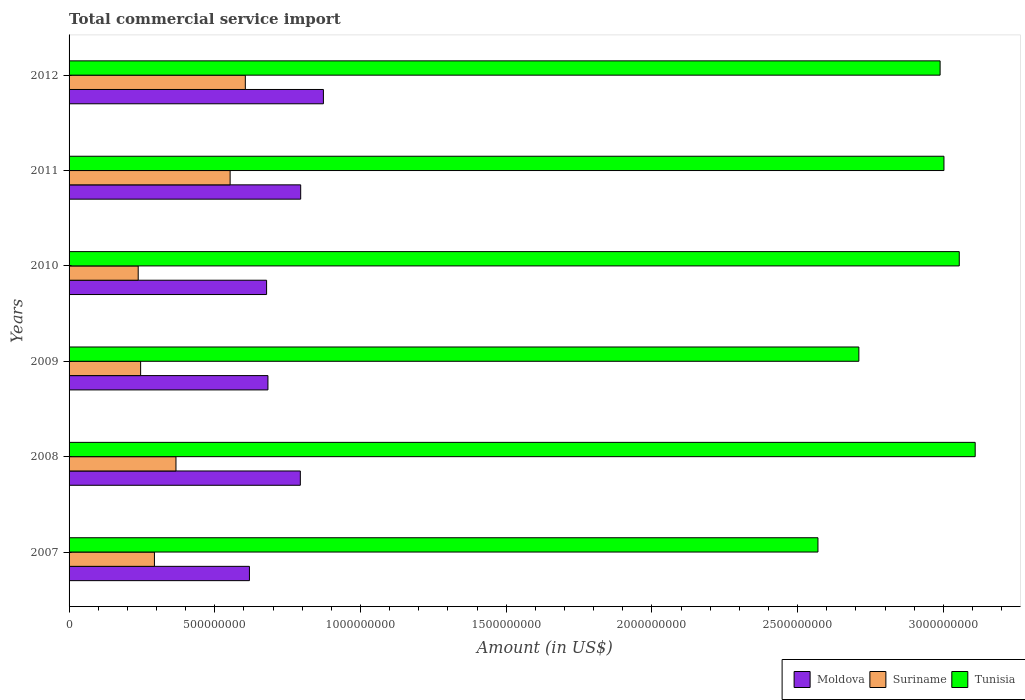How many groups of bars are there?
Make the answer very short. 6. Are the number of bars per tick equal to the number of legend labels?
Ensure brevity in your answer.  Yes. Are the number of bars on each tick of the Y-axis equal?
Make the answer very short. Yes. In how many cases, is the number of bars for a given year not equal to the number of legend labels?
Provide a succinct answer. 0. What is the total commercial service import in Suriname in 2009?
Your answer should be compact. 2.46e+08. Across all years, what is the maximum total commercial service import in Tunisia?
Your answer should be compact. 3.11e+09. Across all years, what is the minimum total commercial service import in Moldova?
Offer a very short reply. 6.19e+08. In which year was the total commercial service import in Suriname maximum?
Provide a short and direct response. 2012. In which year was the total commercial service import in Tunisia minimum?
Give a very brief answer. 2007. What is the total total commercial service import in Moldova in the graph?
Provide a short and direct response. 4.44e+09. What is the difference between the total commercial service import in Suriname in 2007 and that in 2012?
Provide a short and direct response. -3.12e+08. What is the difference between the total commercial service import in Moldova in 2009 and the total commercial service import in Tunisia in 2012?
Your answer should be compact. -2.31e+09. What is the average total commercial service import in Moldova per year?
Make the answer very short. 7.40e+08. In the year 2009, what is the difference between the total commercial service import in Tunisia and total commercial service import in Moldova?
Your answer should be very brief. 2.03e+09. What is the ratio of the total commercial service import in Tunisia in 2007 to that in 2011?
Keep it short and to the point. 0.86. What is the difference between the highest and the second highest total commercial service import in Tunisia?
Make the answer very short. 5.46e+07. What is the difference between the highest and the lowest total commercial service import in Tunisia?
Give a very brief answer. 5.40e+08. In how many years, is the total commercial service import in Moldova greater than the average total commercial service import in Moldova taken over all years?
Offer a terse response. 3. What does the 3rd bar from the top in 2012 represents?
Ensure brevity in your answer.  Moldova. What does the 1st bar from the bottom in 2010 represents?
Your answer should be compact. Moldova. Is it the case that in every year, the sum of the total commercial service import in Moldova and total commercial service import in Tunisia is greater than the total commercial service import in Suriname?
Ensure brevity in your answer.  Yes. How many bars are there?
Your answer should be very brief. 18. How many years are there in the graph?
Give a very brief answer. 6. What is the difference between two consecutive major ticks on the X-axis?
Provide a short and direct response. 5.00e+08. Does the graph contain any zero values?
Offer a terse response. No. What is the title of the graph?
Give a very brief answer. Total commercial service import. Does "East Asia (developing only)" appear as one of the legend labels in the graph?
Offer a terse response. No. What is the label or title of the X-axis?
Give a very brief answer. Amount (in US$). What is the Amount (in US$) of Moldova in 2007?
Your answer should be very brief. 6.19e+08. What is the Amount (in US$) of Suriname in 2007?
Ensure brevity in your answer.  2.93e+08. What is the Amount (in US$) of Tunisia in 2007?
Your answer should be compact. 2.57e+09. What is the Amount (in US$) in Moldova in 2008?
Your response must be concise. 7.94e+08. What is the Amount (in US$) of Suriname in 2008?
Offer a very short reply. 3.67e+08. What is the Amount (in US$) of Tunisia in 2008?
Provide a succinct answer. 3.11e+09. What is the Amount (in US$) in Moldova in 2009?
Your response must be concise. 6.82e+08. What is the Amount (in US$) of Suriname in 2009?
Your answer should be very brief. 2.46e+08. What is the Amount (in US$) in Tunisia in 2009?
Provide a succinct answer. 2.71e+09. What is the Amount (in US$) in Moldova in 2010?
Your answer should be very brief. 6.78e+08. What is the Amount (in US$) of Suriname in 2010?
Your answer should be very brief. 2.37e+08. What is the Amount (in US$) of Tunisia in 2010?
Provide a succinct answer. 3.05e+09. What is the Amount (in US$) of Moldova in 2011?
Your answer should be very brief. 7.95e+08. What is the Amount (in US$) in Suriname in 2011?
Give a very brief answer. 5.53e+08. What is the Amount (in US$) in Tunisia in 2011?
Give a very brief answer. 3.00e+09. What is the Amount (in US$) of Moldova in 2012?
Provide a short and direct response. 8.73e+08. What is the Amount (in US$) in Suriname in 2012?
Provide a succinct answer. 6.05e+08. What is the Amount (in US$) of Tunisia in 2012?
Ensure brevity in your answer.  2.99e+09. Across all years, what is the maximum Amount (in US$) in Moldova?
Your answer should be compact. 8.73e+08. Across all years, what is the maximum Amount (in US$) in Suriname?
Offer a terse response. 6.05e+08. Across all years, what is the maximum Amount (in US$) in Tunisia?
Offer a terse response. 3.11e+09. Across all years, what is the minimum Amount (in US$) in Moldova?
Provide a short and direct response. 6.19e+08. Across all years, what is the minimum Amount (in US$) of Suriname?
Your answer should be very brief. 2.37e+08. Across all years, what is the minimum Amount (in US$) of Tunisia?
Provide a succinct answer. 2.57e+09. What is the total Amount (in US$) of Moldova in the graph?
Your answer should be compact. 4.44e+09. What is the total Amount (in US$) in Suriname in the graph?
Your response must be concise. 2.30e+09. What is the total Amount (in US$) in Tunisia in the graph?
Provide a succinct answer. 1.74e+1. What is the difference between the Amount (in US$) in Moldova in 2007 and that in 2008?
Your answer should be compact. -1.75e+08. What is the difference between the Amount (in US$) in Suriname in 2007 and that in 2008?
Provide a short and direct response. -7.39e+07. What is the difference between the Amount (in US$) of Tunisia in 2007 and that in 2008?
Provide a short and direct response. -5.40e+08. What is the difference between the Amount (in US$) of Moldova in 2007 and that in 2009?
Make the answer very short. -6.35e+07. What is the difference between the Amount (in US$) of Suriname in 2007 and that in 2009?
Offer a terse response. 4.74e+07. What is the difference between the Amount (in US$) of Tunisia in 2007 and that in 2009?
Your response must be concise. -1.40e+08. What is the difference between the Amount (in US$) in Moldova in 2007 and that in 2010?
Offer a terse response. -5.89e+07. What is the difference between the Amount (in US$) in Suriname in 2007 and that in 2010?
Offer a very short reply. 5.57e+07. What is the difference between the Amount (in US$) of Tunisia in 2007 and that in 2010?
Provide a short and direct response. -4.85e+08. What is the difference between the Amount (in US$) of Moldova in 2007 and that in 2011?
Offer a terse response. -1.76e+08. What is the difference between the Amount (in US$) of Suriname in 2007 and that in 2011?
Ensure brevity in your answer.  -2.60e+08. What is the difference between the Amount (in US$) in Tunisia in 2007 and that in 2011?
Offer a very short reply. -4.32e+08. What is the difference between the Amount (in US$) in Moldova in 2007 and that in 2012?
Your response must be concise. -2.54e+08. What is the difference between the Amount (in US$) of Suriname in 2007 and that in 2012?
Your answer should be very brief. -3.12e+08. What is the difference between the Amount (in US$) in Tunisia in 2007 and that in 2012?
Ensure brevity in your answer.  -4.19e+08. What is the difference between the Amount (in US$) of Moldova in 2008 and that in 2009?
Provide a short and direct response. 1.11e+08. What is the difference between the Amount (in US$) of Suriname in 2008 and that in 2009?
Keep it short and to the point. 1.21e+08. What is the difference between the Amount (in US$) of Tunisia in 2008 and that in 2009?
Provide a succinct answer. 3.99e+08. What is the difference between the Amount (in US$) in Moldova in 2008 and that in 2010?
Offer a very short reply. 1.16e+08. What is the difference between the Amount (in US$) of Suriname in 2008 and that in 2010?
Your response must be concise. 1.30e+08. What is the difference between the Amount (in US$) in Tunisia in 2008 and that in 2010?
Offer a very short reply. 5.46e+07. What is the difference between the Amount (in US$) of Moldova in 2008 and that in 2011?
Offer a very short reply. -1.20e+06. What is the difference between the Amount (in US$) of Suriname in 2008 and that in 2011?
Your response must be concise. -1.86e+08. What is the difference between the Amount (in US$) of Tunisia in 2008 and that in 2011?
Offer a very short reply. 1.07e+08. What is the difference between the Amount (in US$) in Moldova in 2008 and that in 2012?
Offer a very short reply. -7.92e+07. What is the difference between the Amount (in US$) of Suriname in 2008 and that in 2012?
Make the answer very short. -2.38e+08. What is the difference between the Amount (in US$) of Tunisia in 2008 and that in 2012?
Ensure brevity in your answer.  1.20e+08. What is the difference between the Amount (in US$) of Moldova in 2009 and that in 2010?
Keep it short and to the point. 4.61e+06. What is the difference between the Amount (in US$) in Suriname in 2009 and that in 2010?
Your response must be concise. 8.30e+06. What is the difference between the Amount (in US$) in Tunisia in 2009 and that in 2010?
Your answer should be very brief. -3.45e+08. What is the difference between the Amount (in US$) of Moldova in 2009 and that in 2011?
Your response must be concise. -1.12e+08. What is the difference between the Amount (in US$) in Suriname in 2009 and that in 2011?
Keep it short and to the point. -3.07e+08. What is the difference between the Amount (in US$) in Tunisia in 2009 and that in 2011?
Give a very brief answer. -2.92e+08. What is the difference between the Amount (in US$) of Moldova in 2009 and that in 2012?
Provide a short and direct response. -1.90e+08. What is the difference between the Amount (in US$) of Suriname in 2009 and that in 2012?
Offer a terse response. -3.59e+08. What is the difference between the Amount (in US$) of Tunisia in 2009 and that in 2012?
Your answer should be compact. -2.79e+08. What is the difference between the Amount (in US$) of Moldova in 2010 and that in 2011?
Ensure brevity in your answer.  -1.17e+08. What is the difference between the Amount (in US$) of Suriname in 2010 and that in 2011?
Provide a succinct answer. -3.15e+08. What is the difference between the Amount (in US$) in Tunisia in 2010 and that in 2011?
Provide a short and direct response. 5.25e+07. What is the difference between the Amount (in US$) in Moldova in 2010 and that in 2012?
Your response must be concise. -1.95e+08. What is the difference between the Amount (in US$) in Suriname in 2010 and that in 2012?
Keep it short and to the point. -3.68e+08. What is the difference between the Amount (in US$) of Tunisia in 2010 and that in 2012?
Keep it short and to the point. 6.57e+07. What is the difference between the Amount (in US$) of Moldova in 2011 and that in 2012?
Offer a terse response. -7.80e+07. What is the difference between the Amount (in US$) in Suriname in 2011 and that in 2012?
Provide a succinct answer. -5.22e+07. What is the difference between the Amount (in US$) of Tunisia in 2011 and that in 2012?
Offer a very short reply. 1.32e+07. What is the difference between the Amount (in US$) of Moldova in 2007 and the Amount (in US$) of Suriname in 2008?
Ensure brevity in your answer.  2.52e+08. What is the difference between the Amount (in US$) in Moldova in 2007 and the Amount (in US$) in Tunisia in 2008?
Your answer should be compact. -2.49e+09. What is the difference between the Amount (in US$) in Suriname in 2007 and the Amount (in US$) in Tunisia in 2008?
Keep it short and to the point. -2.82e+09. What is the difference between the Amount (in US$) in Moldova in 2007 and the Amount (in US$) in Suriname in 2009?
Your response must be concise. 3.73e+08. What is the difference between the Amount (in US$) of Moldova in 2007 and the Amount (in US$) of Tunisia in 2009?
Keep it short and to the point. -2.09e+09. What is the difference between the Amount (in US$) in Suriname in 2007 and the Amount (in US$) in Tunisia in 2009?
Keep it short and to the point. -2.42e+09. What is the difference between the Amount (in US$) in Moldova in 2007 and the Amount (in US$) in Suriname in 2010?
Ensure brevity in your answer.  3.82e+08. What is the difference between the Amount (in US$) of Moldova in 2007 and the Amount (in US$) of Tunisia in 2010?
Your answer should be very brief. -2.44e+09. What is the difference between the Amount (in US$) of Suriname in 2007 and the Amount (in US$) of Tunisia in 2010?
Give a very brief answer. -2.76e+09. What is the difference between the Amount (in US$) of Moldova in 2007 and the Amount (in US$) of Suriname in 2011?
Provide a succinct answer. 6.63e+07. What is the difference between the Amount (in US$) in Moldova in 2007 and the Amount (in US$) in Tunisia in 2011?
Ensure brevity in your answer.  -2.38e+09. What is the difference between the Amount (in US$) of Suriname in 2007 and the Amount (in US$) of Tunisia in 2011?
Give a very brief answer. -2.71e+09. What is the difference between the Amount (in US$) of Moldova in 2007 and the Amount (in US$) of Suriname in 2012?
Offer a terse response. 1.41e+07. What is the difference between the Amount (in US$) in Moldova in 2007 and the Amount (in US$) in Tunisia in 2012?
Keep it short and to the point. -2.37e+09. What is the difference between the Amount (in US$) of Suriname in 2007 and the Amount (in US$) of Tunisia in 2012?
Provide a succinct answer. -2.70e+09. What is the difference between the Amount (in US$) of Moldova in 2008 and the Amount (in US$) of Suriname in 2009?
Keep it short and to the point. 5.48e+08. What is the difference between the Amount (in US$) in Moldova in 2008 and the Amount (in US$) in Tunisia in 2009?
Provide a short and direct response. -1.92e+09. What is the difference between the Amount (in US$) in Suriname in 2008 and the Amount (in US$) in Tunisia in 2009?
Give a very brief answer. -2.34e+09. What is the difference between the Amount (in US$) of Moldova in 2008 and the Amount (in US$) of Suriname in 2010?
Provide a short and direct response. 5.56e+08. What is the difference between the Amount (in US$) in Moldova in 2008 and the Amount (in US$) in Tunisia in 2010?
Offer a terse response. -2.26e+09. What is the difference between the Amount (in US$) in Suriname in 2008 and the Amount (in US$) in Tunisia in 2010?
Offer a very short reply. -2.69e+09. What is the difference between the Amount (in US$) of Moldova in 2008 and the Amount (in US$) of Suriname in 2011?
Your answer should be very brief. 2.41e+08. What is the difference between the Amount (in US$) of Moldova in 2008 and the Amount (in US$) of Tunisia in 2011?
Make the answer very short. -2.21e+09. What is the difference between the Amount (in US$) in Suriname in 2008 and the Amount (in US$) in Tunisia in 2011?
Keep it short and to the point. -2.64e+09. What is the difference between the Amount (in US$) of Moldova in 2008 and the Amount (in US$) of Suriname in 2012?
Offer a terse response. 1.89e+08. What is the difference between the Amount (in US$) of Moldova in 2008 and the Amount (in US$) of Tunisia in 2012?
Offer a terse response. -2.20e+09. What is the difference between the Amount (in US$) in Suriname in 2008 and the Amount (in US$) in Tunisia in 2012?
Your response must be concise. -2.62e+09. What is the difference between the Amount (in US$) of Moldova in 2009 and the Amount (in US$) of Suriname in 2010?
Your answer should be compact. 4.45e+08. What is the difference between the Amount (in US$) of Moldova in 2009 and the Amount (in US$) of Tunisia in 2010?
Your answer should be very brief. -2.37e+09. What is the difference between the Amount (in US$) in Suriname in 2009 and the Amount (in US$) in Tunisia in 2010?
Your response must be concise. -2.81e+09. What is the difference between the Amount (in US$) of Moldova in 2009 and the Amount (in US$) of Suriname in 2011?
Give a very brief answer. 1.30e+08. What is the difference between the Amount (in US$) in Moldova in 2009 and the Amount (in US$) in Tunisia in 2011?
Your response must be concise. -2.32e+09. What is the difference between the Amount (in US$) in Suriname in 2009 and the Amount (in US$) in Tunisia in 2011?
Your response must be concise. -2.76e+09. What is the difference between the Amount (in US$) of Moldova in 2009 and the Amount (in US$) of Suriname in 2012?
Your answer should be very brief. 7.76e+07. What is the difference between the Amount (in US$) in Moldova in 2009 and the Amount (in US$) in Tunisia in 2012?
Offer a terse response. -2.31e+09. What is the difference between the Amount (in US$) in Suriname in 2009 and the Amount (in US$) in Tunisia in 2012?
Provide a short and direct response. -2.74e+09. What is the difference between the Amount (in US$) of Moldova in 2010 and the Amount (in US$) of Suriname in 2011?
Make the answer very short. 1.25e+08. What is the difference between the Amount (in US$) of Moldova in 2010 and the Amount (in US$) of Tunisia in 2011?
Keep it short and to the point. -2.32e+09. What is the difference between the Amount (in US$) in Suriname in 2010 and the Amount (in US$) in Tunisia in 2011?
Your answer should be very brief. -2.76e+09. What is the difference between the Amount (in US$) in Moldova in 2010 and the Amount (in US$) in Suriname in 2012?
Your answer should be compact. 7.30e+07. What is the difference between the Amount (in US$) in Moldova in 2010 and the Amount (in US$) in Tunisia in 2012?
Keep it short and to the point. -2.31e+09. What is the difference between the Amount (in US$) of Suriname in 2010 and the Amount (in US$) of Tunisia in 2012?
Keep it short and to the point. -2.75e+09. What is the difference between the Amount (in US$) in Moldova in 2011 and the Amount (in US$) in Suriname in 2012?
Offer a very short reply. 1.90e+08. What is the difference between the Amount (in US$) of Moldova in 2011 and the Amount (in US$) of Tunisia in 2012?
Your answer should be compact. -2.19e+09. What is the difference between the Amount (in US$) in Suriname in 2011 and the Amount (in US$) in Tunisia in 2012?
Ensure brevity in your answer.  -2.44e+09. What is the average Amount (in US$) of Moldova per year?
Offer a terse response. 7.40e+08. What is the average Amount (in US$) of Suriname per year?
Keep it short and to the point. 3.83e+08. What is the average Amount (in US$) in Tunisia per year?
Your response must be concise. 2.91e+09. In the year 2007, what is the difference between the Amount (in US$) in Moldova and Amount (in US$) in Suriname?
Ensure brevity in your answer.  3.26e+08. In the year 2007, what is the difference between the Amount (in US$) in Moldova and Amount (in US$) in Tunisia?
Your response must be concise. -1.95e+09. In the year 2007, what is the difference between the Amount (in US$) of Suriname and Amount (in US$) of Tunisia?
Give a very brief answer. -2.28e+09. In the year 2008, what is the difference between the Amount (in US$) of Moldova and Amount (in US$) of Suriname?
Your answer should be compact. 4.27e+08. In the year 2008, what is the difference between the Amount (in US$) of Moldova and Amount (in US$) of Tunisia?
Ensure brevity in your answer.  -2.32e+09. In the year 2008, what is the difference between the Amount (in US$) of Suriname and Amount (in US$) of Tunisia?
Ensure brevity in your answer.  -2.74e+09. In the year 2009, what is the difference between the Amount (in US$) of Moldova and Amount (in US$) of Suriname?
Your answer should be compact. 4.37e+08. In the year 2009, what is the difference between the Amount (in US$) of Moldova and Amount (in US$) of Tunisia?
Provide a succinct answer. -2.03e+09. In the year 2009, what is the difference between the Amount (in US$) of Suriname and Amount (in US$) of Tunisia?
Offer a very short reply. -2.46e+09. In the year 2010, what is the difference between the Amount (in US$) in Moldova and Amount (in US$) in Suriname?
Your response must be concise. 4.41e+08. In the year 2010, what is the difference between the Amount (in US$) of Moldova and Amount (in US$) of Tunisia?
Give a very brief answer. -2.38e+09. In the year 2010, what is the difference between the Amount (in US$) in Suriname and Amount (in US$) in Tunisia?
Provide a short and direct response. -2.82e+09. In the year 2011, what is the difference between the Amount (in US$) of Moldova and Amount (in US$) of Suriname?
Keep it short and to the point. 2.42e+08. In the year 2011, what is the difference between the Amount (in US$) of Moldova and Amount (in US$) of Tunisia?
Give a very brief answer. -2.21e+09. In the year 2011, what is the difference between the Amount (in US$) of Suriname and Amount (in US$) of Tunisia?
Ensure brevity in your answer.  -2.45e+09. In the year 2012, what is the difference between the Amount (in US$) in Moldova and Amount (in US$) in Suriname?
Make the answer very short. 2.68e+08. In the year 2012, what is the difference between the Amount (in US$) of Moldova and Amount (in US$) of Tunisia?
Ensure brevity in your answer.  -2.12e+09. In the year 2012, what is the difference between the Amount (in US$) in Suriname and Amount (in US$) in Tunisia?
Your response must be concise. -2.38e+09. What is the ratio of the Amount (in US$) of Moldova in 2007 to that in 2008?
Provide a succinct answer. 0.78. What is the ratio of the Amount (in US$) of Suriname in 2007 to that in 2008?
Keep it short and to the point. 0.8. What is the ratio of the Amount (in US$) of Tunisia in 2007 to that in 2008?
Provide a succinct answer. 0.83. What is the ratio of the Amount (in US$) of Moldova in 2007 to that in 2009?
Your response must be concise. 0.91. What is the ratio of the Amount (in US$) of Suriname in 2007 to that in 2009?
Your response must be concise. 1.19. What is the ratio of the Amount (in US$) of Tunisia in 2007 to that in 2009?
Give a very brief answer. 0.95. What is the ratio of the Amount (in US$) in Moldova in 2007 to that in 2010?
Ensure brevity in your answer.  0.91. What is the ratio of the Amount (in US$) in Suriname in 2007 to that in 2010?
Offer a terse response. 1.23. What is the ratio of the Amount (in US$) in Tunisia in 2007 to that in 2010?
Ensure brevity in your answer.  0.84. What is the ratio of the Amount (in US$) in Moldova in 2007 to that in 2011?
Your answer should be very brief. 0.78. What is the ratio of the Amount (in US$) in Suriname in 2007 to that in 2011?
Offer a terse response. 0.53. What is the ratio of the Amount (in US$) in Tunisia in 2007 to that in 2011?
Provide a short and direct response. 0.86. What is the ratio of the Amount (in US$) of Moldova in 2007 to that in 2012?
Provide a short and direct response. 0.71. What is the ratio of the Amount (in US$) in Suriname in 2007 to that in 2012?
Your response must be concise. 0.48. What is the ratio of the Amount (in US$) of Tunisia in 2007 to that in 2012?
Make the answer very short. 0.86. What is the ratio of the Amount (in US$) of Moldova in 2008 to that in 2009?
Your response must be concise. 1.16. What is the ratio of the Amount (in US$) of Suriname in 2008 to that in 2009?
Your answer should be compact. 1.49. What is the ratio of the Amount (in US$) in Tunisia in 2008 to that in 2009?
Your answer should be compact. 1.15. What is the ratio of the Amount (in US$) of Moldova in 2008 to that in 2010?
Your response must be concise. 1.17. What is the ratio of the Amount (in US$) in Suriname in 2008 to that in 2010?
Keep it short and to the point. 1.55. What is the ratio of the Amount (in US$) in Tunisia in 2008 to that in 2010?
Make the answer very short. 1.02. What is the ratio of the Amount (in US$) in Suriname in 2008 to that in 2011?
Your answer should be very brief. 0.66. What is the ratio of the Amount (in US$) of Tunisia in 2008 to that in 2011?
Your answer should be compact. 1.04. What is the ratio of the Amount (in US$) of Moldova in 2008 to that in 2012?
Your answer should be very brief. 0.91. What is the ratio of the Amount (in US$) of Suriname in 2008 to that in 2012?
Your answer should be compact. 0.61. What is the ratio of the Amount (in US$) of Tunisia in 2008 to that in 2012?
Your response must be concise. 1.04. What is the ratio of the Amount (in US$) in Moldova in 2009 to that in 2010?
Keep it short and to the point. 1.01. What is the ratio of the Amount (in US$) of Suriname in 2009 to that in 2010?
Keep it short and to the point. 1.03. What is the ratio of the Amount (in US$) of Tunisia in 2009 to that in 2010?
Keep it short and to the point. 0.89. What is the ratio of the Amount (in US$) of Moldova in 2009 to that in 2011?
Make the answer very short. 0.86. What is the ratio of the Amount (in US$) in Suriname in 2009 to that in 2011?
Provide a succinct answer. 0.44. What is the ratio of the Amount (in US$) of Tunisia in 2009 to that in 2011?
Provide a succinct answer. 0.9. What is the ratio of the Amount (in US$) in Moldova in 2009 to that in 2012?
Offer a very short reply. 0.78. What is the ratio of the Amount (in US$) in Suriname in 2009 to that in 2012?
Provide a succinct answer. 0.41. What is the ratio of the Amount (in US$) of Tunisia in 2009 to that in 2012?
Offer a very short reply. 0.91. What is the ratio of the Amount (in US$) in Moldova in 2010 to that in 2011?
Give a very brief answer. 0.85. What is the ratio of the Amount (in US$) in Suriname in 2010 to that in 2011?
Offer a very short reply. 0.43. What is the ratio of the Amount (in US$) of Tunisia in 2010 to that in 2011?
Provide a succinct answer. 1.02. What is the ratio of the Amount (in US$) of Moldova in 2010 to that in 2012?
Provide a succinct answer. 0.78. What is the ratio of the Amount (in US$) in Suriname in 2010 to that in 2012?
Give a very brief answer. 0.39. What is the ratio of the Amount (in US$) in Tunisia in 2010 to that in 2012?
Provide a short and direct response. 1.02. What is the ratio of the Amount (in US$) in Moldova in 2011 to that in 2012?
Provide a short and direct response. 0.91. What is the ratio of the Amount (in US$) of Suriname in 2011 to that in 2012?
Give a very brief answer. 0.91. What is the difference between the highest and the second highest Amount (in US$) of Moldova?
Your answer should be compact. 7.80e+07. What is the difference between the highest and the second highest Amount (in US$) in Suriname?
Keep it short and to the point. 5.22e+07. What is the difference between the highest and the second highest Amount (in US$) of Tunisia?
Your answer should be compact. 5.46e+07. What is the difference between the highest and the lowest Amount (in US$) of Moldova?
Make the answer very short. 2.54e+08. What is the difference between the highest and the lowest Amount (in US$) of Suriname?
Ensure brevity in your answer.  3.68e+08. What is the difference between the highest and the lowest Amount (in US$) of Tunisia?
Provide a short and direct response. 5.40e+08. 